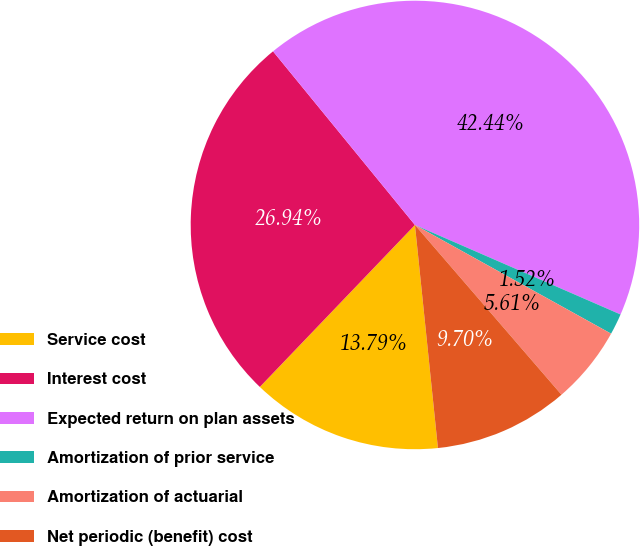Convert chart to OTSL. <chart><loc_0><loc_0><loc_500><loc_500><pie_chart><fcel>Service cost<fcel>Interest cost<fcel>Expected return on plan assets<fcel>Amortization of prior service<fcel>Amortization of actuarial<fcel>Net periodic (benefit) cost<nl><fcel>13.79%<fcel>26.94%<fcel>42.44%<fcel>1.52%<fcel>5.61%<fcel>9.7%<nl></chart> 